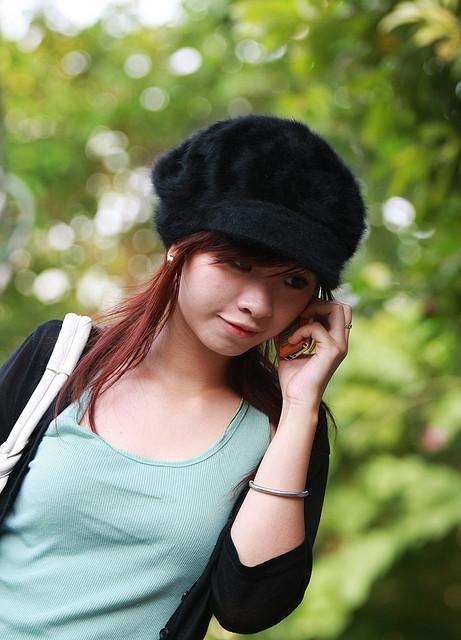Is the girl wearing jewelry?
Short answer required. Yes. What is this person doing?
Keep it brief. Talking on phone. Is this person indoors?
Keep it brief. No. 